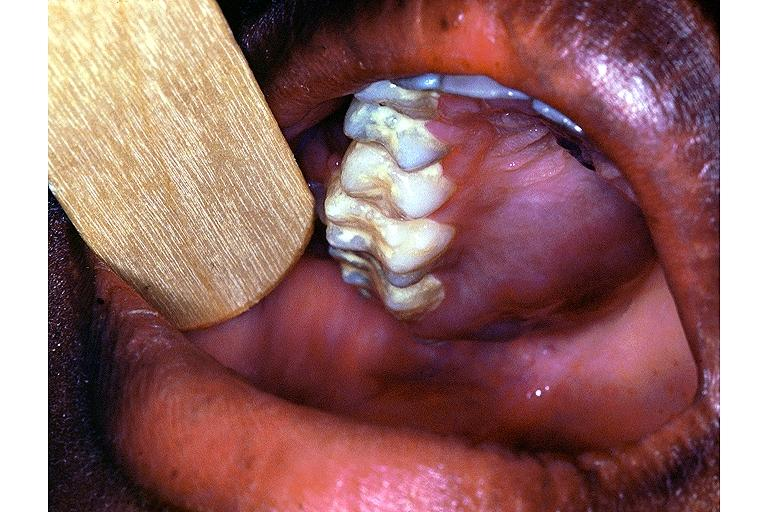s leg present?
Answer the question using a single word or phrase. No 